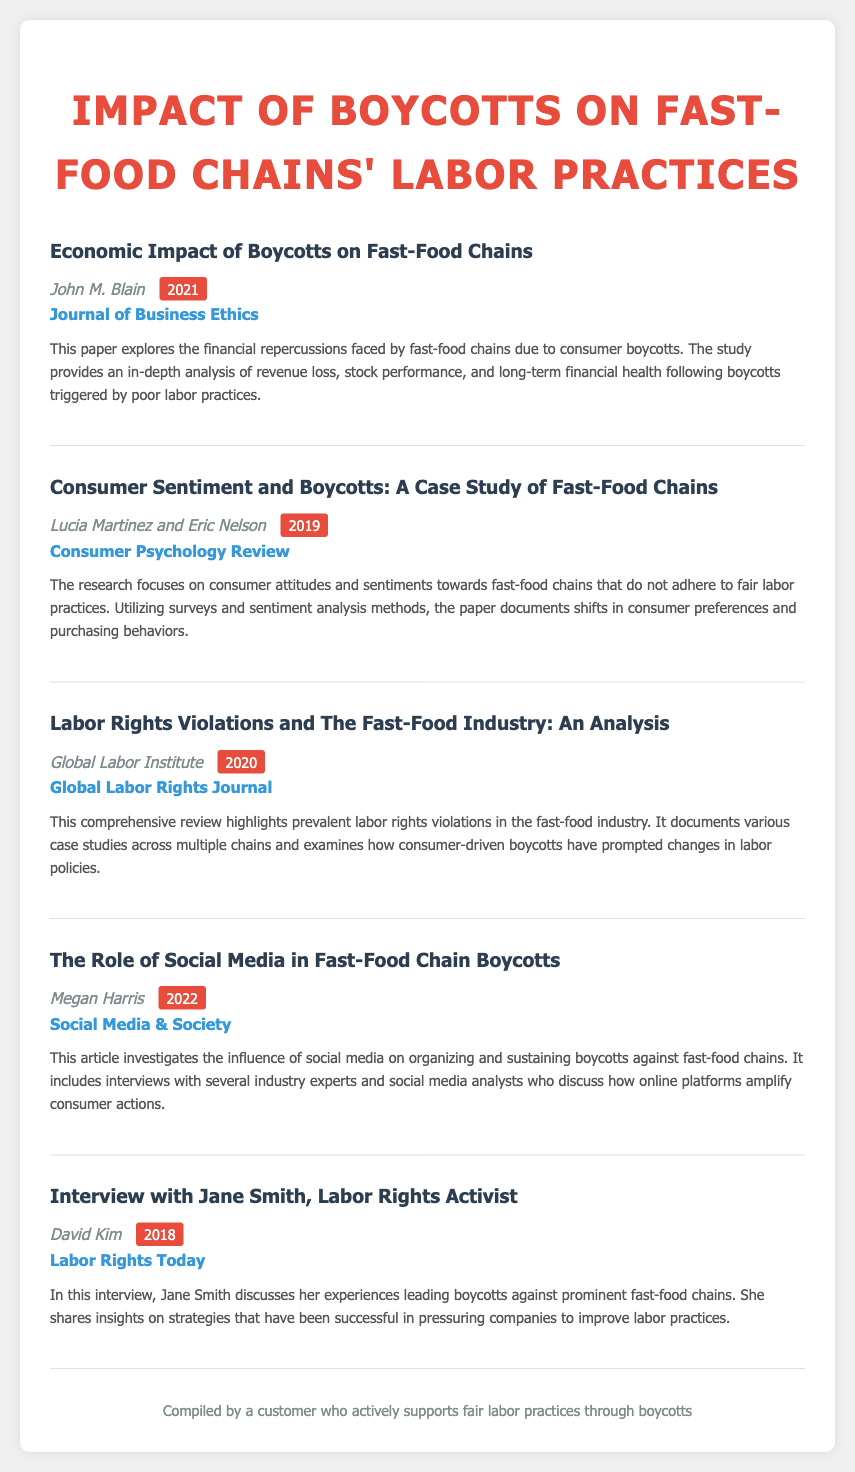What is the title of the first entry? The title of the first entry is the main focus of the citation, which is "Economic Impact of Boycotts on Fast-Food Chains."
Answer: Economic Impact of Boycotts on Fast-Food Chains Who authored the second entry? The authors of the second entry are listed immediately below the title, which are Lucia Martinez and Eric Nelson.
Answer: Lucia Martinez and Eric Nelson What year was the article "The Role of Social Media in Fast-Food Chain Boycotts" published? The year of publication for this entry is indicated in parentheses next to the author's name, which is 2022.
Answer: 2022 How many entries are listed in total? The total number of entries is counted by examining the main content areas, which include five distinct entries.
Answer: Five What is the primary focus of the third entry? The primary focus of the third entry is revealed in the title and summary, which discusses labor rights violations in the fast-food industry.
Answer: Labor rights violations What type of source is the entry by John M. Blain? The source is categorized by the document type specified in the entry, which is a journal, as seen in the citation details.
Answer: Journal of Business Ethics What is the summary keyword of Megan Harris's article? The keyword summarizing the article relates to the influence of online platforms on boycotts, specifically indicated in the title as "social media."
Answer: Social media Who conducted the interview with Jane Smith? The person who conducted the interview is indicated by the author's name mentioned below the title, which is David Kim.
Answer: David Kim 